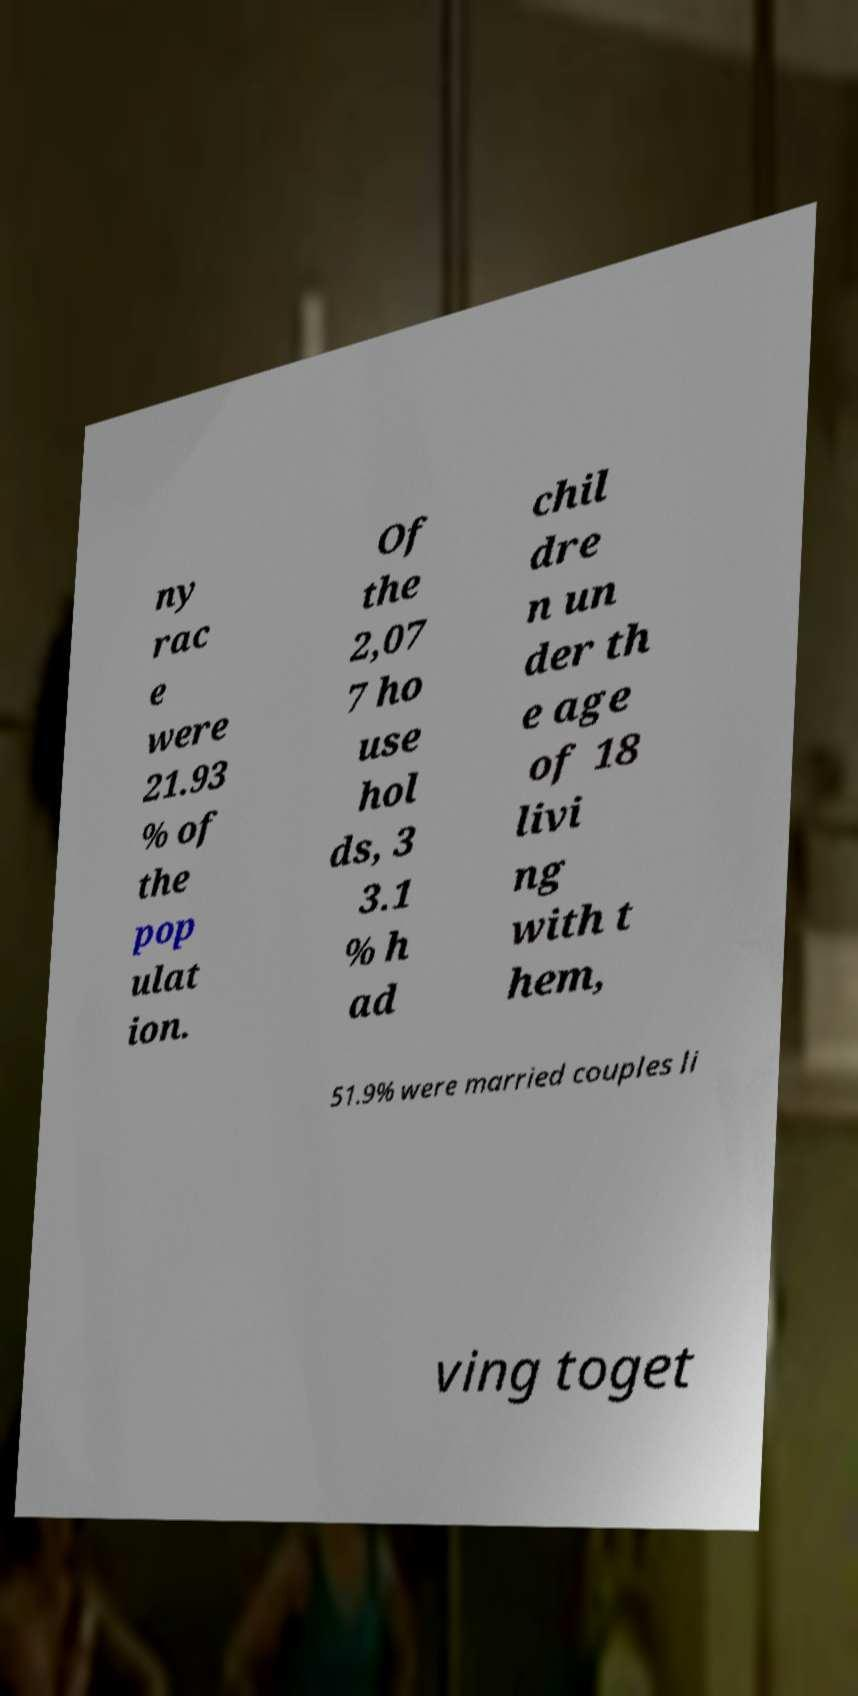Please identify and transcribe the text found in this image. ny rac e were 21.93 % of the pop ulat ion. Of the 2,07 7 ho use hol ds, 3 3.1 % h ad chil dre n un der th e age of 18 livi ng with t hem, 51.9% were married couples li ving toget 